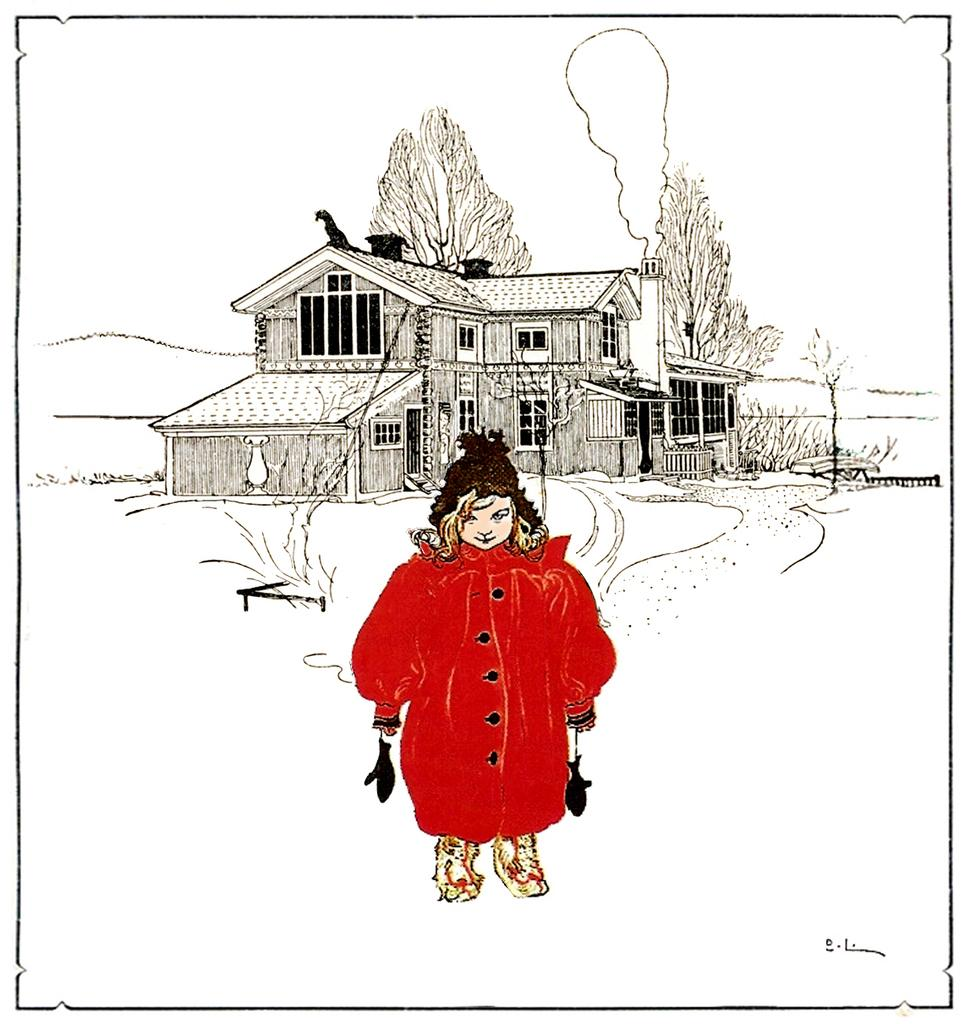What type of artwork is the image? The image is a painting. What type of structure is depicted in the painting? There is a house in the image. What type of plant is shown in the painting? There is a tree in the image. Are there any human figures in the painting? Yes, there is a person in the image. What type of pathway is present in the painting? There is a road in the image. Can you see any icicles hanging from the tree in the painting? There are no icicles present in the painting; it does not depict any icy conditions. What type of stick is the person holding in the painting? There is no stick present in the painting; the person is not holding any object. 